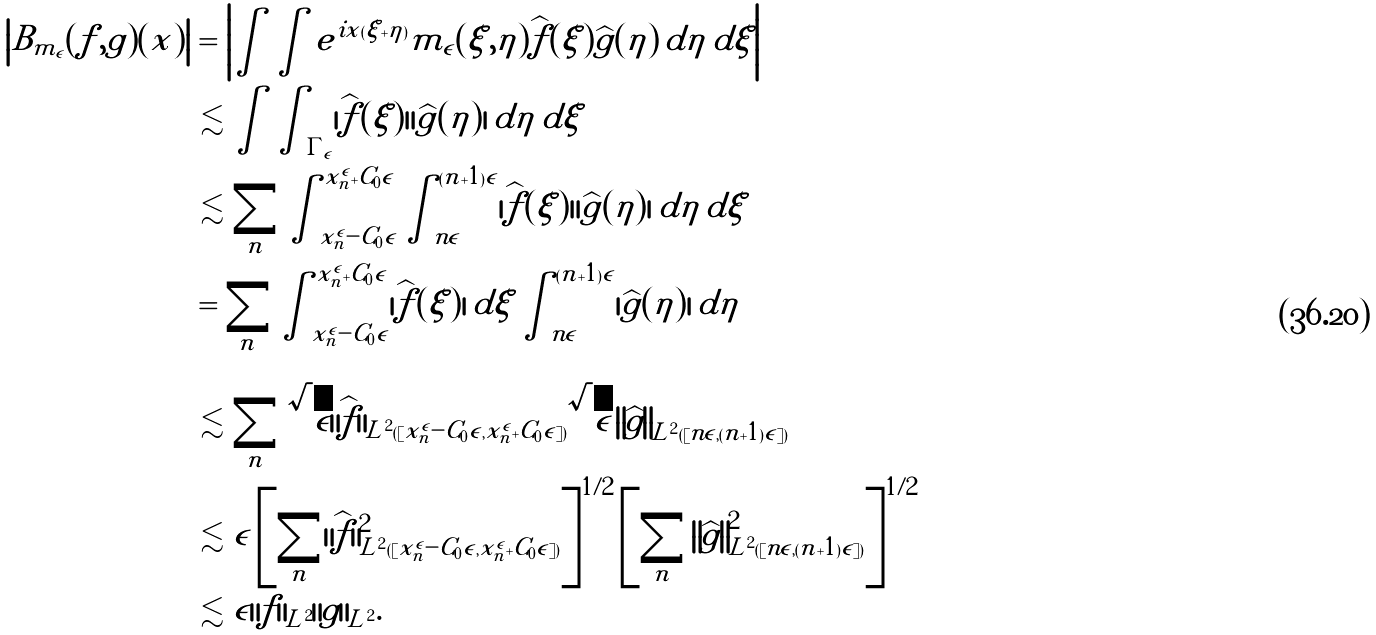<formula> <loc_0><loc_0><loc_500><loc_500>\left | B _ { m _ { \epsilon } } ( f , g ) ( x ) \right | & = \left | \int \int e ^ { i x ( \xi + \eta ) } m _ { \epsilon } ( \xi , \eta ) \widehat { f } ( \xi ) \widehat { g } ( \eta ) \, d \eta \, d \xi \right | \\ & \lesssim \int \int _ { \Gamma _ { \epsilon } } | \widehat { f } ( \xi ) | | \widehat { g } ( \eta ) | \, d \eta \, d \xi \\ & \lesssim \sum _ { n } \int _ { x _ { n } ^ { \epsilon } - C _ { 0 } \epsilon } ^ { x _ { n } ^ { \epsilon } + C _ { 0 } \epsilon } \int _ { n \epsilon } ^ { ( n + 1 ) \epsilon } | \widehat { f } ( \xi ) | | \widehat { g } ( \eta ) | \, d \eta \, d \xi \\ & = \sum _ { n } \int _ { x _ { n } ^ { \epsilon } - C _ { 0 } \epsilon } ^ { x _ { n } ^ { \epsilon } + C _ { 0 } \epsilon } | \widehat { f } ( \xi ) | \, d \xi \int _ { n \epsilon } ^ { ( n + 1 ) \epsilon } | \widehat { g } ( \eta ) | \, d \eta \\ & \lesssim \sum _ { n } \sqrt { \epsilon } \| \widehat { f } \| _ { L ^ { 2 } ( [ x _ { n } ^ { \epsilon } - C _ { 0 } \epsilon , x _ { n } ^ { \epsilon } + C _ { 0 } \epsilon ] ) } \sqrt { \epsilon } \left \| \widehat { g } \right \| _ { L ^ { 2 } ( [ n \epsilon , ( n + 1 ) \epsilon ] ) } \\ & \lesssim \epsilon \left [ \sum _ { n } \| \widehat { f } \| _ { L ^ { 2 } ( [ x _ { n } ^ { \epsilon } - C _ { 0 } \epsilon , x _ { n } ^ { \epsilon } + C _ { 0 } \epsilon ] ) } ^ { 2 } \right ] ^ { 1 / 2 } \left [ \sum _ { n } \left \| \widehat { g } \right \| _ { L ^ { 2 } ( [ n \epsilon , ( n + 1 ) \epsilon ] ) } ^ { 2 } \right ] ^ { 1 / 2 } \\ & \lesssim \epsilon \| f \| _ { L ^ { 2 } } \| g \| _ { L ^ { 2 } } .</formula> 